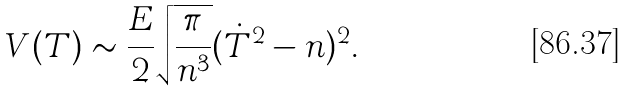Convert formula to latex. <formula><loc_0><loc_0><loc_500><loc_500>V ( T ) \sim \frac { E } { 2 } \sqrt { \frac { \pi } { n ^ { 3 } } } ( \dot { T } ^ { 2 } - n ) ^ { 2 } .</formula> 